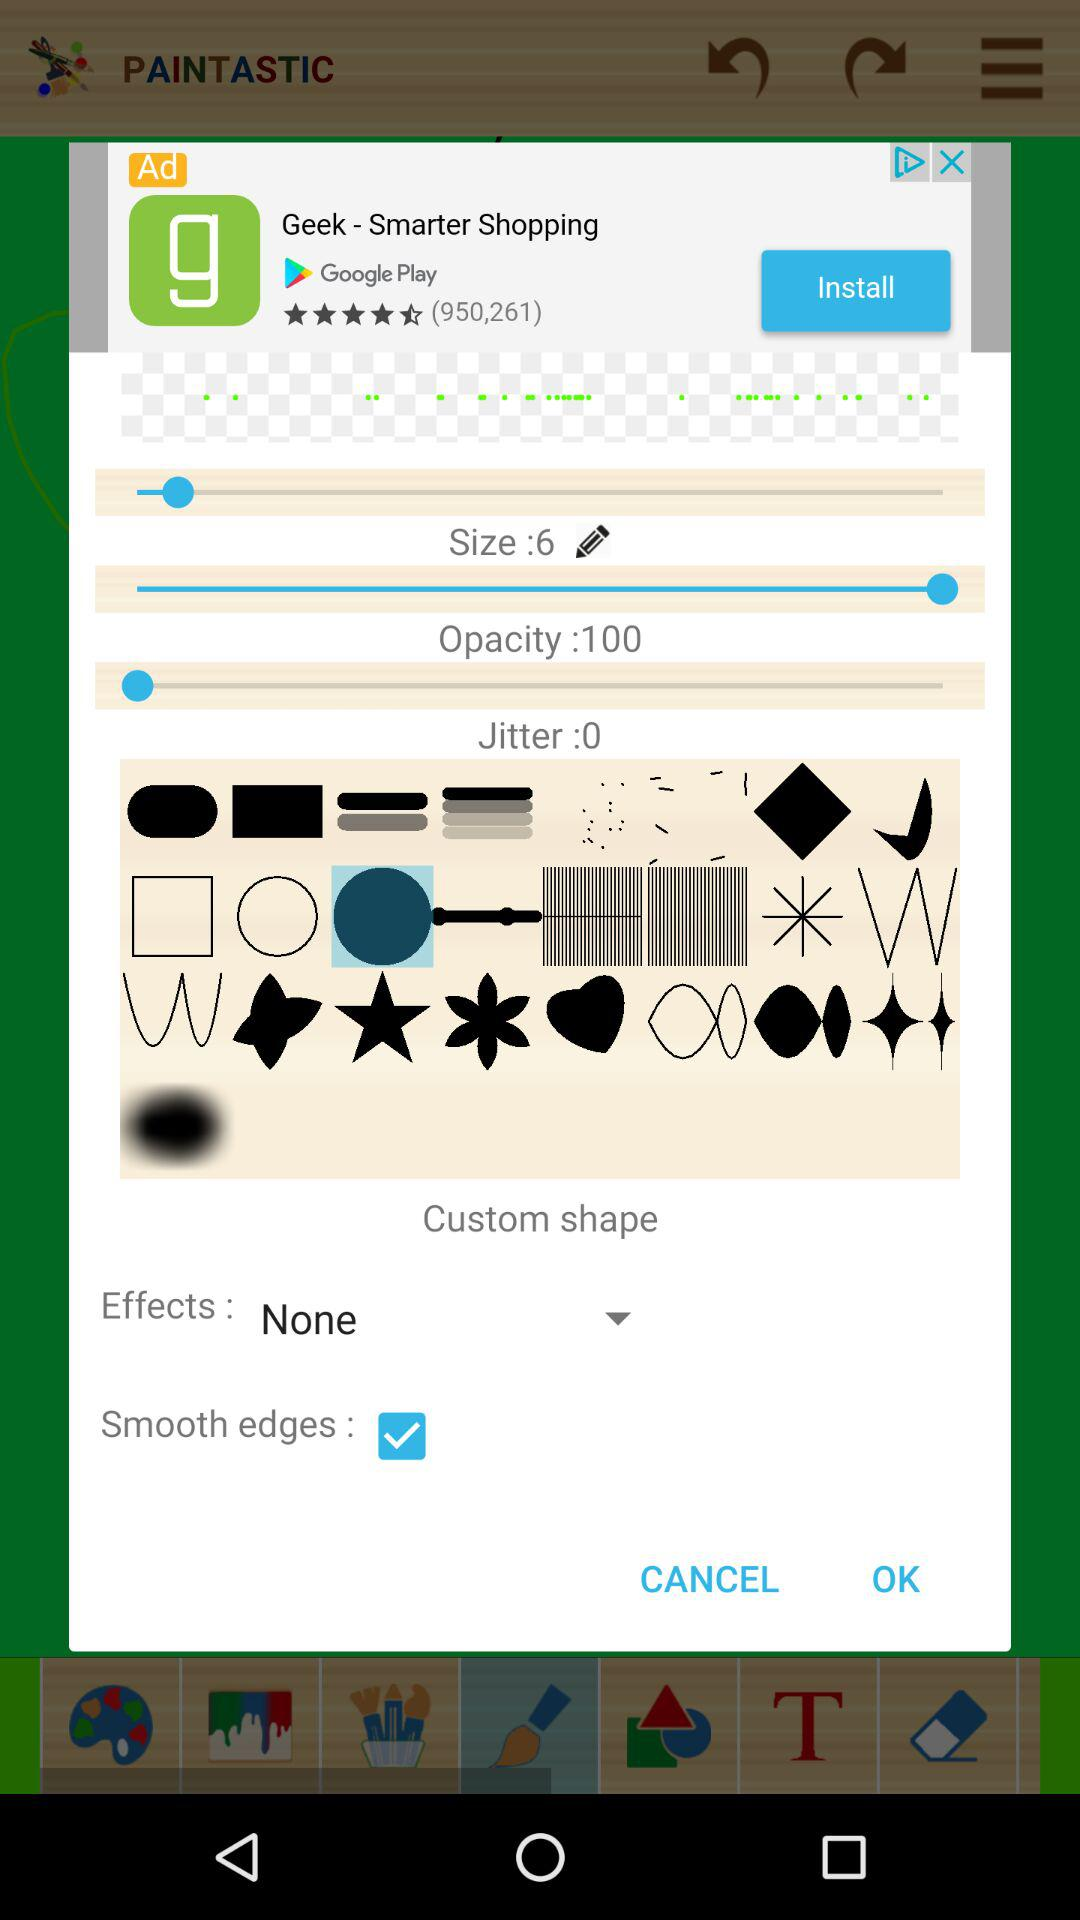What's the opacity? The opacity is 100. 